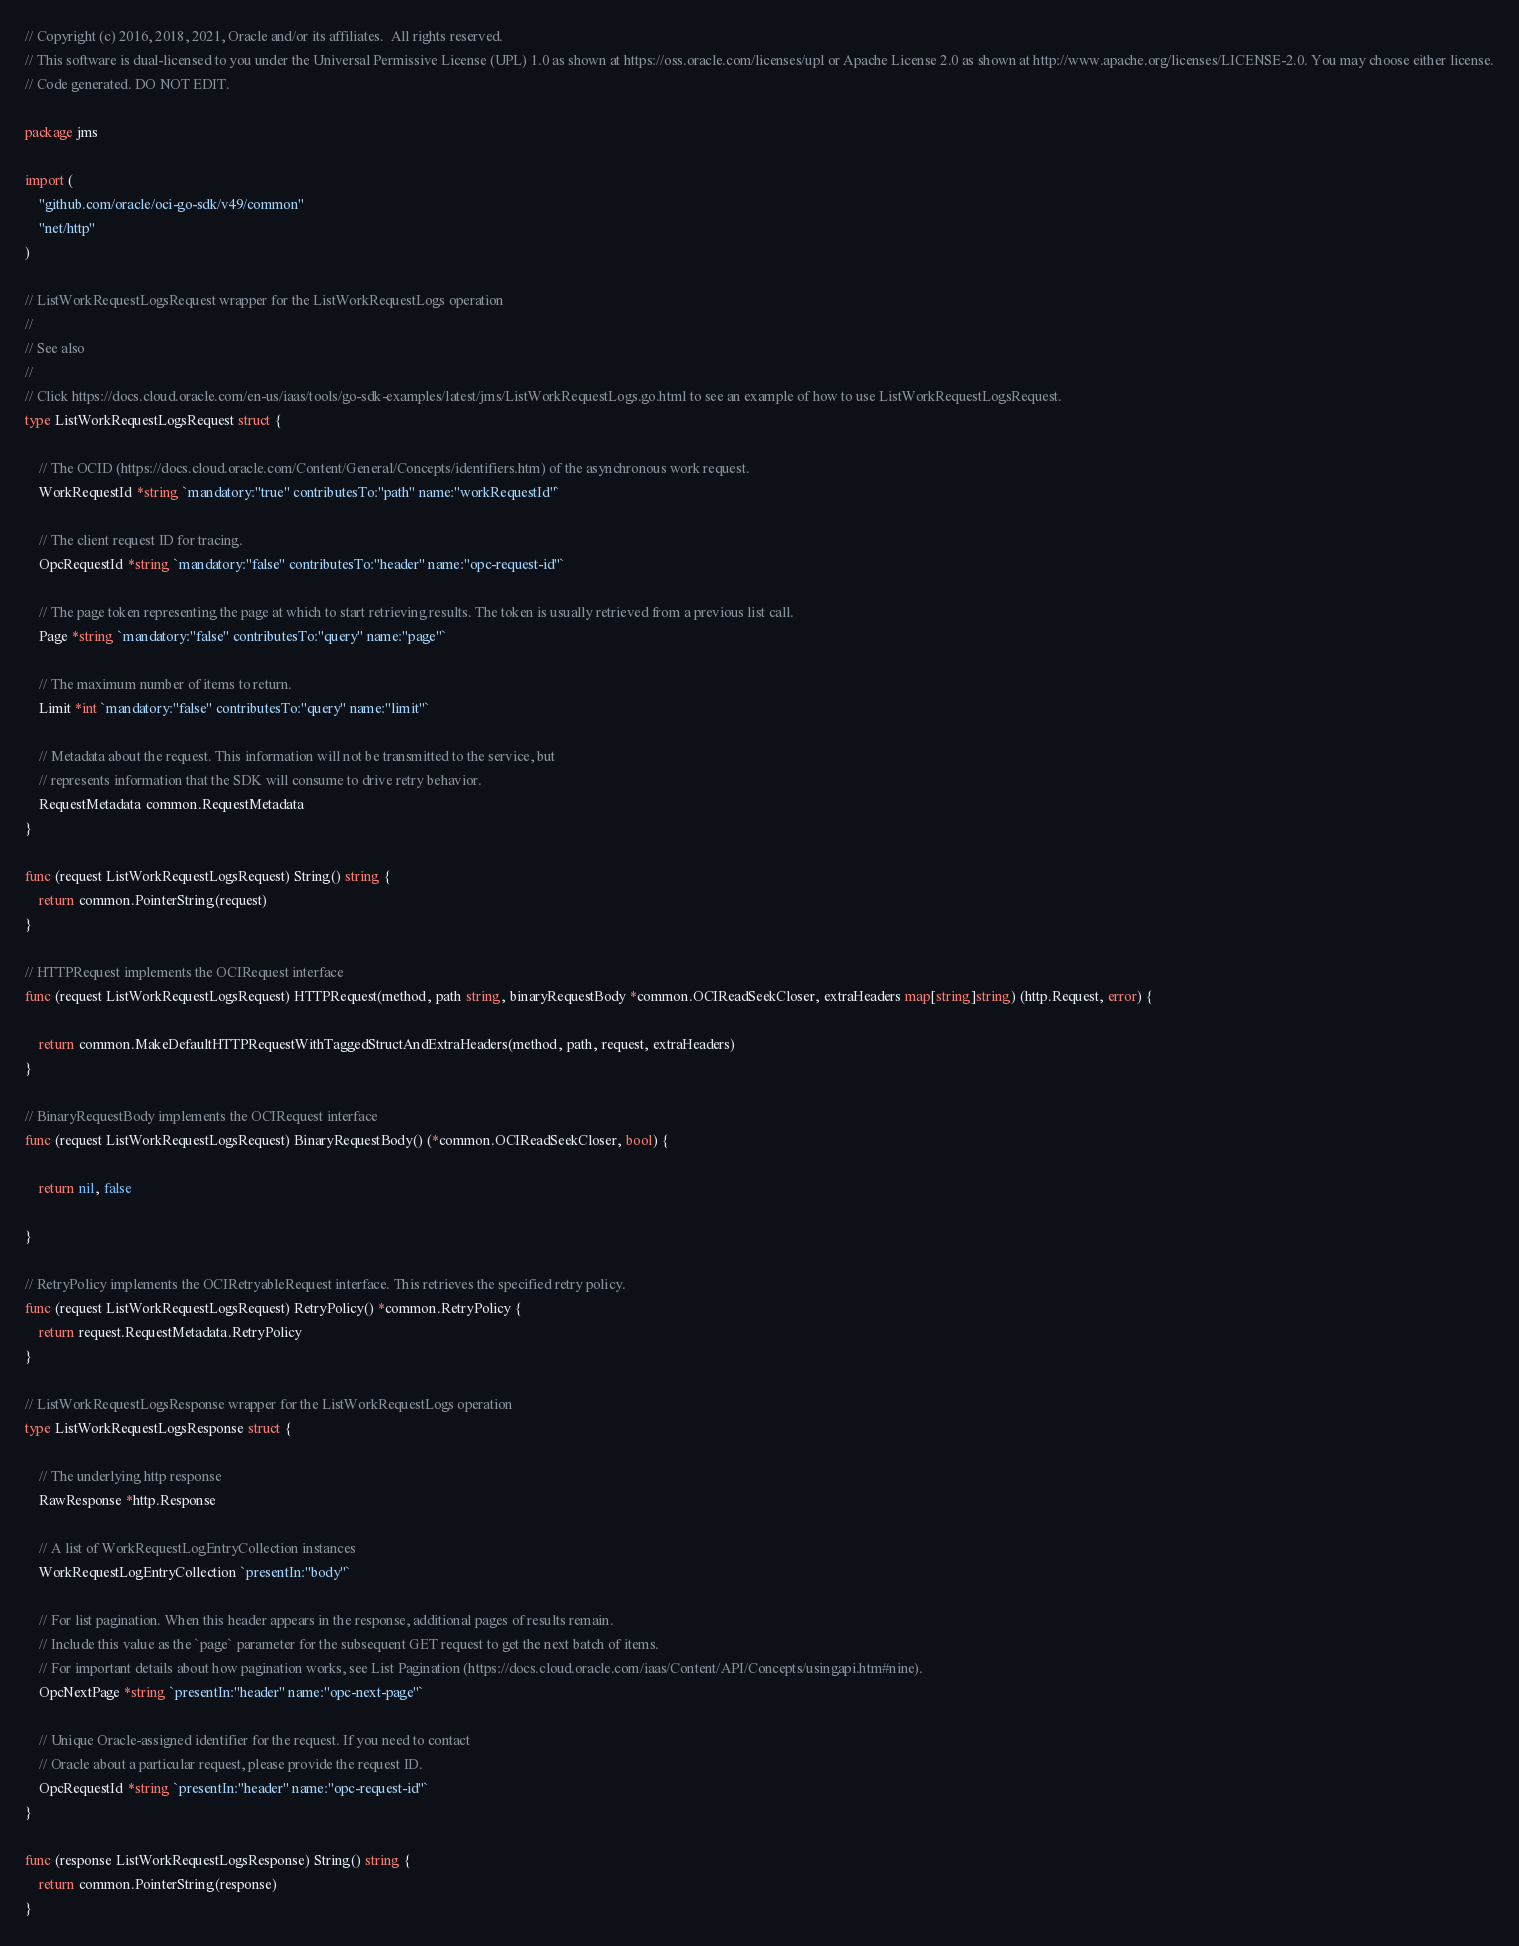Convert code to text. <code><loc_0><loc_0><loc_500><loc_500><_Go_>// Copyright (c) 2016, 2018, 2021, Oracle and/or its affiliates.  All rights reserved.
// This software is dual-licensed to you under the Universal Permissive License (UPL) 1.0 as shown at https://oss.oracle.com/licenses/upl or Apache License 2.0 as shown at http://www.apache.org/licenses/LICENSE-2.0. You may choose either license.
// Code generated. DO NOT EDIT.

package jms

import (
	"github.com/oracle/oci-go-sdk/v49/common"
	"net/http"
)

// ListWorkRequestLogsRequest wrapper for the ListWorkRequestLogs operation
//
// See also
//
// Click https://docs.cloud.oracle.com/en-us/iaas/tools/go-sdk-examples/latest/jms/ListWorkRequestLogs.go.html to see an example of how to use ListWorkRequestLogsRequest.
type ListWorkRequestLogsRequest struct {

	// The OCID (https://docs.cloud.oracle.com/Content/General/Concepts/identifiers.htm) of the asynchronous work request.
	WorkRequestId *string `mandatory:"true" contributesTo:"path" name:"workRequestId"`

	// The client request ID for tracing.
	OpcRequestId *string `mandatory:"false" contributesTo:"header" name:"opc-request-id"`

	// The page token representing the page at which to start retrieving results. The token is usually retrieved from a previous list call.
	Page *string `mandatory:"false" contributesTo:"query" name:"page"`

	// The maximum number of items to return.
	Limit *int `mandatory:"false" contributesTo:"query" name:"limit"`

	// Metadata about the request. This information will not be transmitted to the service, but
	// represents information that the SDK will consume to drive retry behavior.
	RequestMetadata common.RequestMetadata
}

func (request ListWorkRequestLogsRequest) String() string {
	return common.PointerString(request)
}

// HTTPRequest implements the OCIRequest interface
func (request ListWorkRequestLogsRequest) HTTPRequest(method, path string, binaryRequestBody *common.OCIReadSeekCloser, extraHeaders map[string]string) (http.Request, error) {

	return common.MakeDefaultHTTPRequestWithTaggedStructAndExtraHeaders(method, path, request, extraHeaders)
}

// BinaryRequestBody implements the OCIRequest interface
func (request ListWorkRequestLogsRequest) BinaryRequestBody() (*common.OCIReadSeekCloser, bool) {

	return nil, false

}

// RetryPolicy implements the OCIRetryableRequest interface. This retrieves the specified retry policy.
func (request ListWorkRequestLogsRequest) RetryPolicy() *common.RetryPolicy {
	return request.RequestMetadata.RetryPolicy
}

// ListWorkRequestLogsResponse wrapper for the ListWorkRequestLogs operation
type ListWorkRequestLogsResponse struct {

	// The underlying http response
	RawResponse *http.Response

	// A list of WorkRequestLogEntryCollection instances
	WorkRequestLogEntryCollection `presentIn:"body"`

	// For list pagination. When this header appears in the response, additional pages of results remain.
	// Include this value as the `page` parameter for the subsequent GET request to get the next batch of items.
	// For important details about how pagination works, see List Pagination (https://docs.cloud.oracle.com/iaas/Content/API/Concepts/usingapi.htm#nine).
	OpcNextPage *string `presentIn:"header" name:"opc-next-page"`

	// Unique Oracle-assigned identifier for the request. If you need to contact
	// Oracle about a particular request, please provide the request ID.
	OpcRequestId *string `presentIn:"header" name:"opc-request-id"`
}

func (response ListWorkRequestLogsResponse) String() string {
	return common.PointerString(response)
}
</code> 